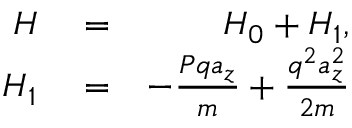Convert formula to latex. <formula><loc_0><loc_0><loc_500><loc_500>\begin{array} { r l r } { H } & = } & { H _ { 0 } + H _ { 1 } , } \\ { H _ { 1 } } & = } & { - \frac { P q a _ { z } } { m } + \frac { q ^ { 2 } a _ { z } ^ { 2 } } { 2 m } } \end{array}</formula> 